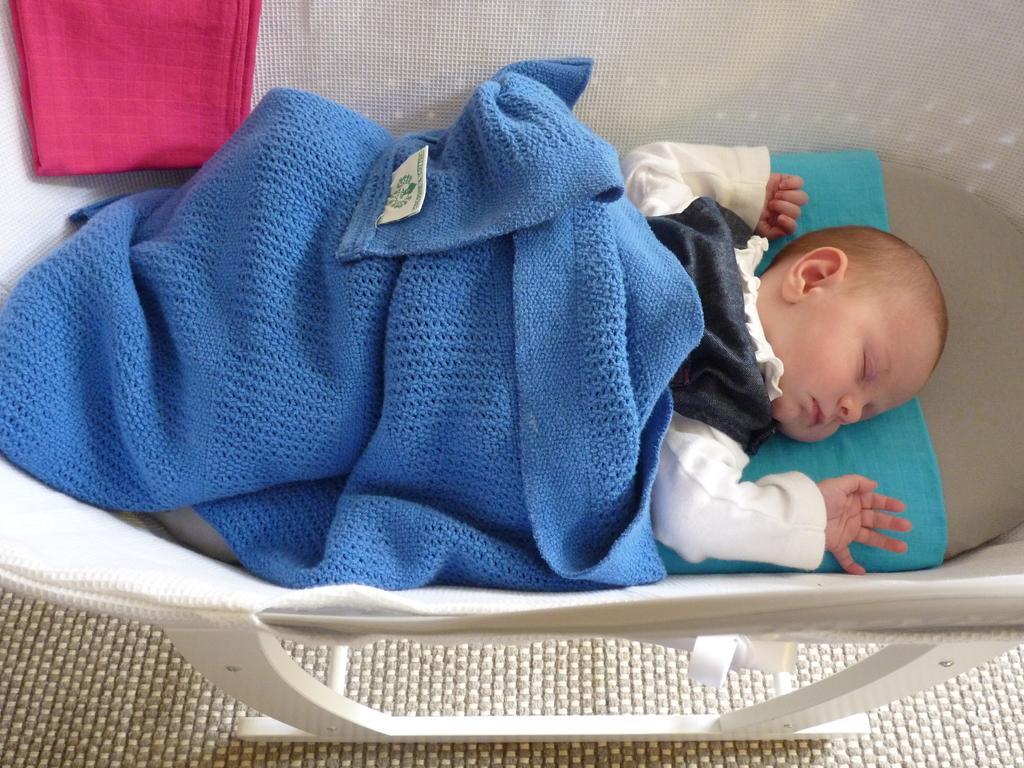In one or two sentences, can you explain what this image depicts? In this image I can see a baby is laying in a cradle which is placed on the floor. On the baby there is a blue color bed sheet. At the top of the image there is a pink color cloth on the cradle. 